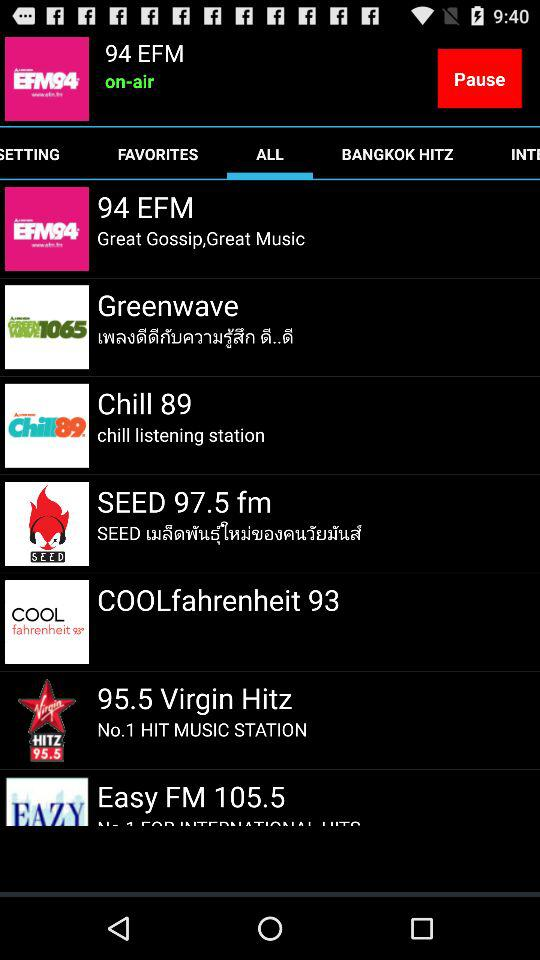Which tab is selected? The selected tab is "ALL". 